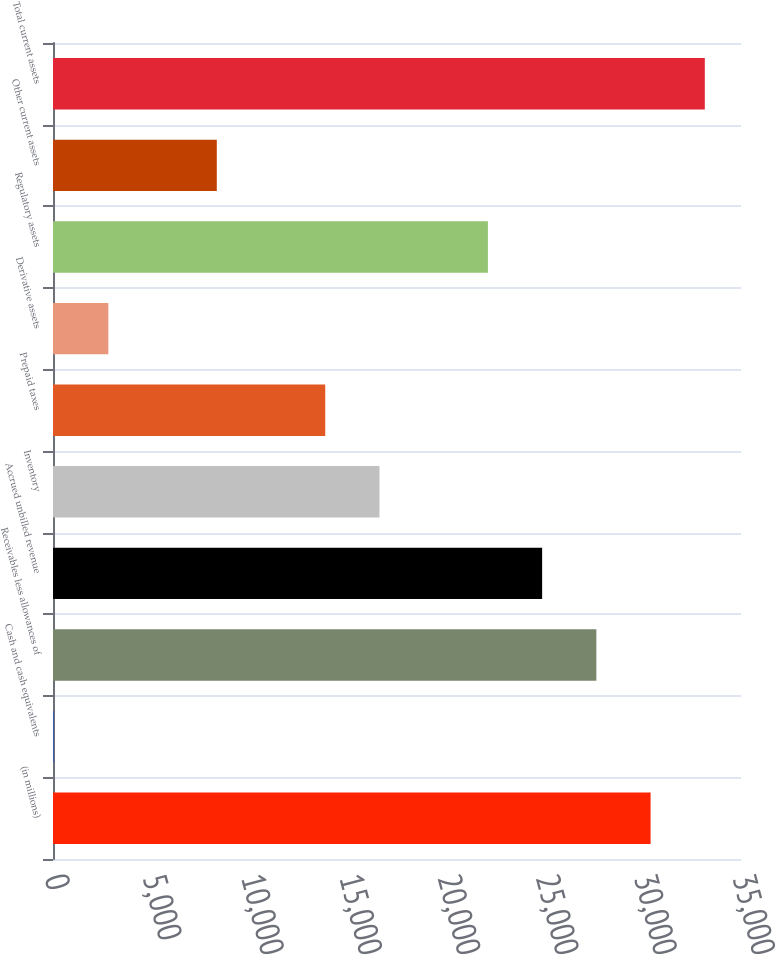Convert chart. <chart><loc_0><loc_0><loc_500><loc_500><bar_chart><fcel>(in millions)<fcel>Cash and cash equivalents<fcel>Receivables less allowances of<fcel>Accrued unbilled revenue<fcel>Inventory<fcel>Prepaid taxes<fcel>Derivative assets<fcel>Regulatory assets<fcel>Other current assets<fcel>Total current assets<nl><fcel>30400.5<fcel>57<fcel>27642<fcel>24883.5<fcel>16608<fcel>13849.5<fcel>2815.5<fcel>22125<fcel>8332.5<fcel>33159<nl></chart> 